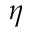Convert formula to latex. <formula><loc_0><loc_0><loc_500><loc_500>\eta</formula> 